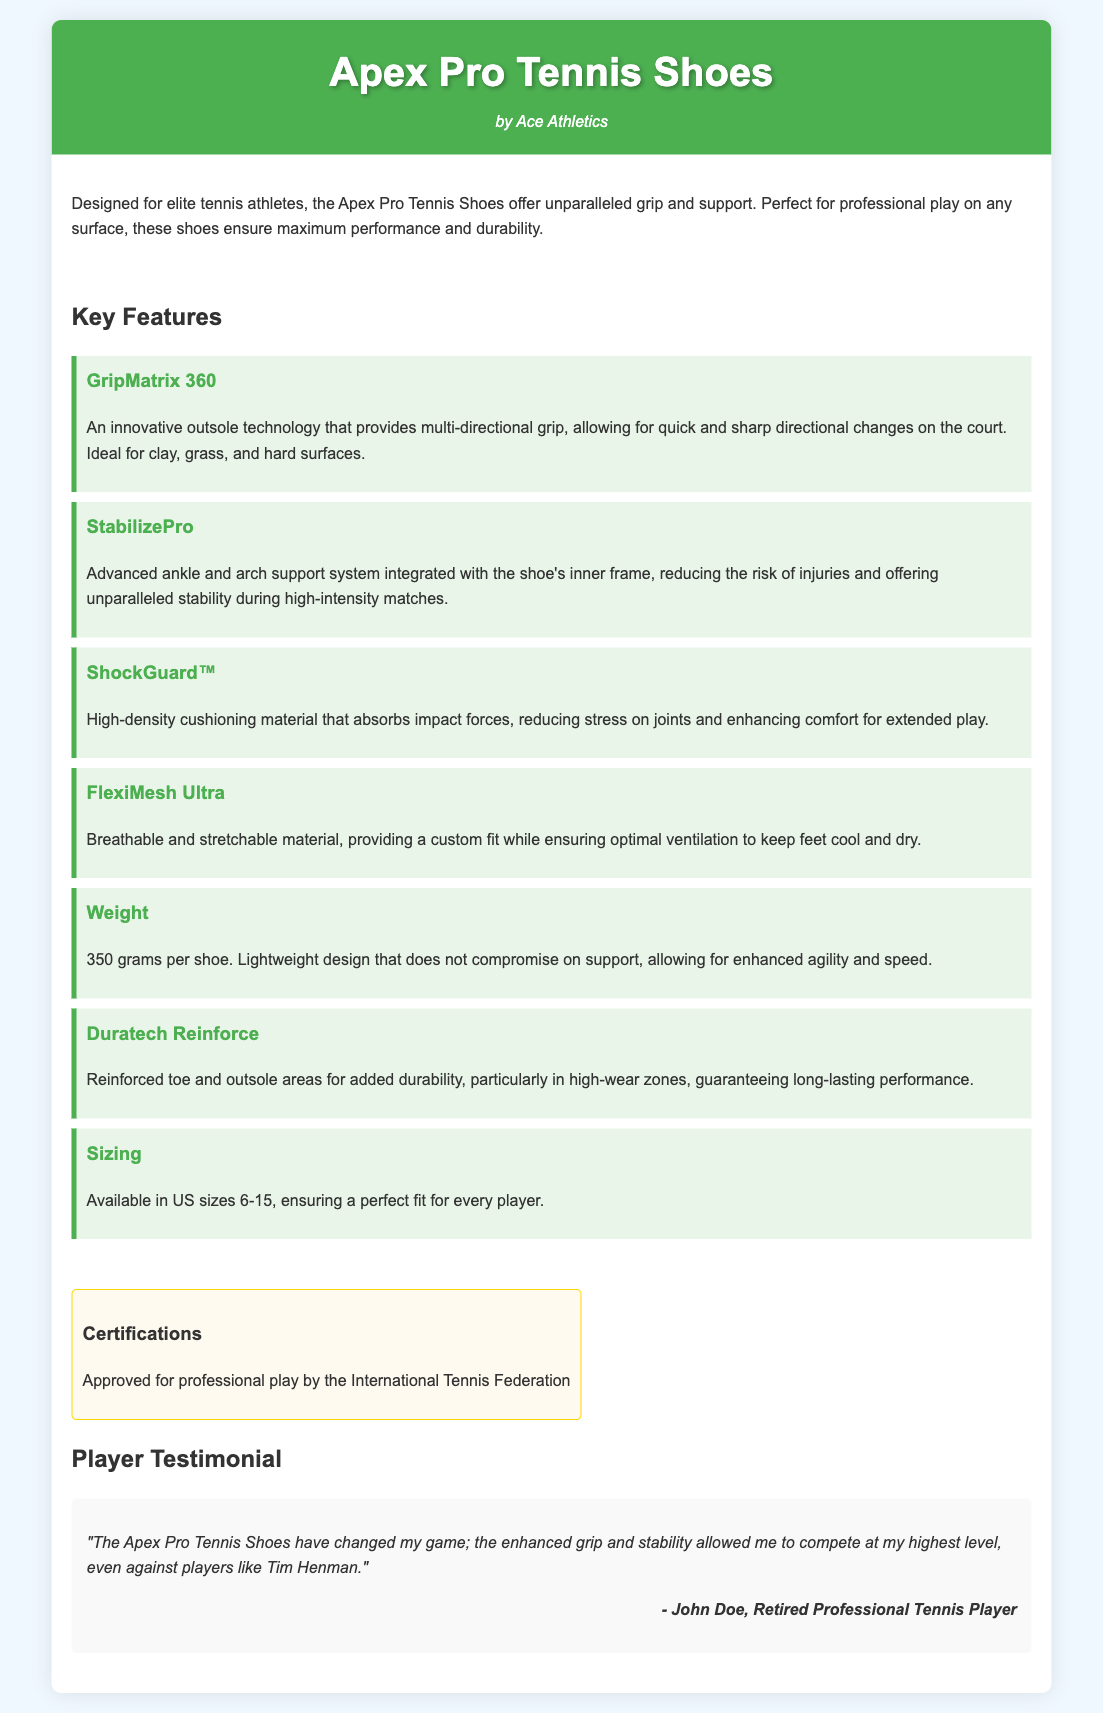What is the brand of the shoes? The brand of the shoes is mentioned in the header of the document as Ace Athletics.
Answer: Ace Athletics What is the weight of each shoe? The weight is specified in the features section stating it is 350 grams per shoe.
Answer: 350 grams What technology does the shoe utilize for grip? The technology for grip is listed under the features section as GripMatrix 360.
Answer: GripMatrix 360 What certification do the shoes have? The certification is noted in the document as being approved for professional play by the International Tennis Federation.
Answer: International Tennis Federation How many sizes are available for the shoes? The sizing information states that there are US sizes available from 6 to 15, which counts as 10 sizes.
Answer: 10 sizes What feature helps reduce stress on joints? The feature that helps reduce stress on joints is mentioned as ShockGuard™ in the features section.
Answer: ShockGuard™ Which material provides a custom fit? The material that provides a custom fit is FlexiMesh Ultra, described in the features section.
Answer: FlexiMesh Ultra Who provided the testimonial? The testimonial is credited to John Doe, as noted in the testimonials section.
Answer: John Doe What is the primary purpose of the Apex Pro Tennis Shoes? The primary purpose is described in the introduction as designed for elite tennis athletes, ensuring maximum performance and durability.
Answer: Maximum performance and durability 